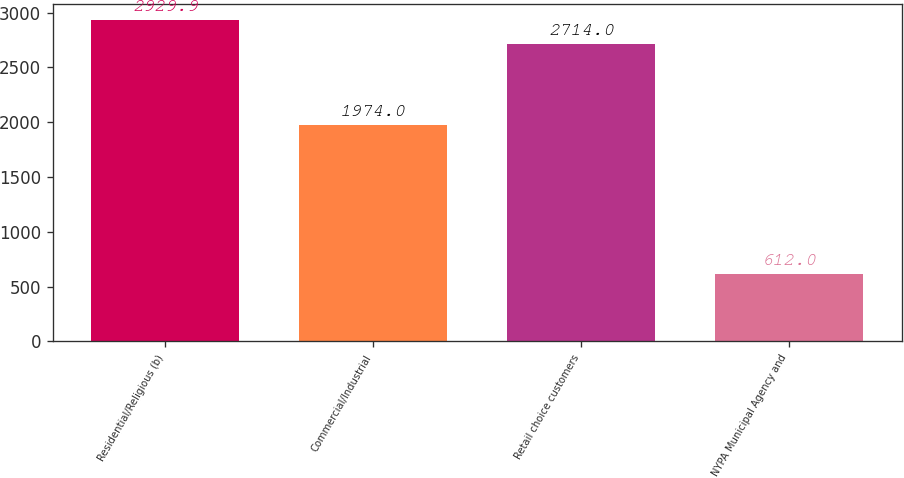Convert chart. <chart><loc_0><loc_0><loc_500><loc_500><bar_chart><fcel>Residential/Religious (b)<fcel>Commercial/Industrial<fcel>Retail choice customers<fcel>NYPA Municipal Agency and<nl><fcel>2929.9<fcel>1974<fcel>2714<fcel>612<nl></chart> 